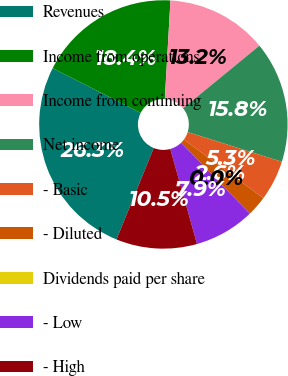Convert chart to OTSL. <chart><loc_0><loc_0><loc_500><loc_500><pie_chart><fcel>Revenues<fcel>Income from operations<fcel>Income from continuing<fcel>Net income<fcel>- Basic<fcel>- Diluted<fcel>Dividends paid per share<fcel>- Low<fcel>- High<nl><fcel>26.32%<fcel>18.42%<fcel>13.16%<fcel>15.79%<fcel>5.26%<fcel>2.63%<fcel>0.0%<fcel>7.89%<fcel>10.53%<nl></chart> 